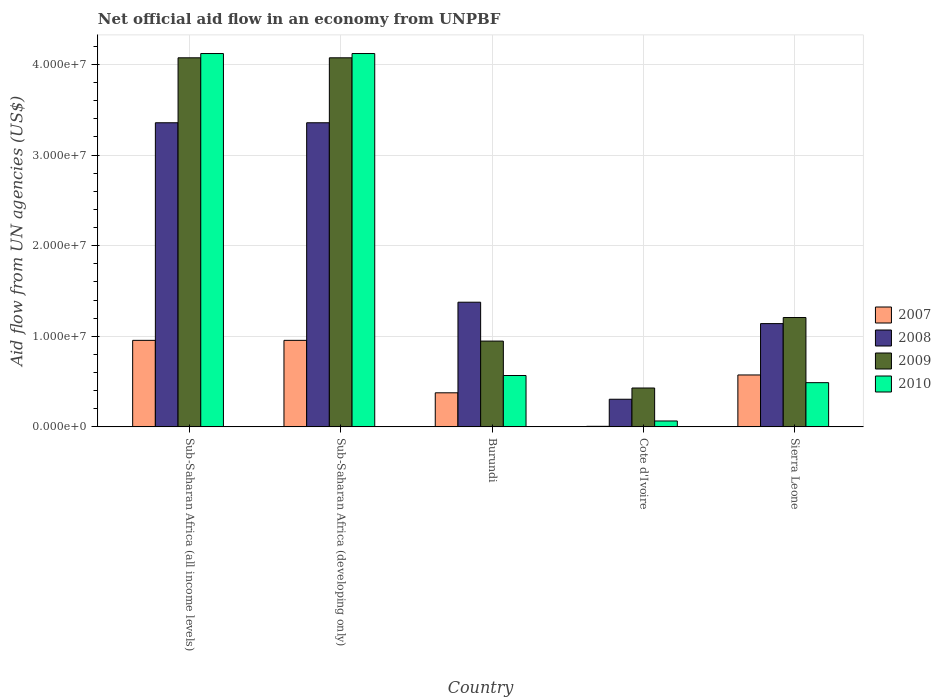How many different coloured bars are there?
Offer a terse response. 4. Are the number of bars per tick equal to the number of legend labels?
Your answer should be very brief. Yes. Are the number of bars on each tick of the X-axis equal?
Offer a very short reply. Yes. How many bars are there on the 4th tick from the left?
Your answer should be very brief. 4. What is the label of the 4th group of bars from the left?
Give a very brief answer. Cote d'Ivoire. In how many cases, is the number of bars for a given country not equal to the number of legend labels?
Offer a very short reply. 0. What is the net official aid flow in 2010 in Sub-Saharan Africa (all income levels)?
Provide a succinct answer. 4.12e+07. Across all countries, what is the maximum net official aid flow in 2008?
Ensure brevity in your answer.  3.36e+07. Across all countries, what is the minimum net official aid flow in 2008?
Keep it short and to the point. 3.05e+06. In which country was the net official aid flow in 2009 maximum?
Your response must be concise. Sub-Saharan Africa (all income levels). In which country was the net official aid flow in 2008 minimum?
Your answer should be compact. Cote d'Ivoire. What is the total net official aid flow in 2009 in the graph?
Provide a short and direct response. 1.07e+08. What is the difference between the net official aid flow in 2009 in Burundi and that in Sub-Saharan Africa (developing only)?
Provide a short and direct response. -3.13e+07. What is the difference between the net official aid flow in 2008 in Sierra Leone and the net official aid flow in 2010 in Sub-Saharan Africa (all income levels)?
Provide a short and direct response. -2.98e+07. What is the average net official aid flow in 2009 per country?
Make the answer very short. 2.15e+07. What is the difference between the net official aid flow of/in 2007 and net official aid flow of/in 2009 in Sub-Saharan Africa (developing only)?
Provide a succinct answer. -3.12e+07. In how many countries, is the net official aid flow in 2007 greater than 36000000 US$?
Make the answer very short. 0. What is the ratio of the net official aid flow in 2009 in Cote d'Ivoire to that in Sub-Saharan Africa (developing only)?
Your answer should be very brief. 0.11. Is the net official aid flow in 2010 in Burundi less than that in Cote d'Ivoire?
Keep it short and to the point. No. Is the difference between the net official aid flow in 2007 in Sub-Saharan Africa (all income levels) and Sub-Saharan Africa (developing only) greater than the difference between the net official aid flow in 2009 in Sub-Saharan Africa (all income levels) and Sub-Saharan Africa (developing only)?
Give a very brief answer. No. What is the difference between the highest and the second highest net official aid flow in 2010?
Your answer should be very brief. 3.55e+07. What is the difference between the highest and the lowest net official aid flow in 2007?
Offer a terse response. 9.49e+06. What does the 4th bar from the left in Burundi represents?
Your answer should be compact. 2010. What does the 1st bar from the right in Cote d'Ivoire represents?
Ensure brevity in your answer.  2010. Are all the bars in the graph horizontal?
Offer a very short reply. No. How many countries are there in the graph?
Keep it short and to the point. 5. What is the difference between two consecutive major ticks on the Y-axis?
Ensure brevity in your answer.  1.00e+07. Are the values on the major ticks of Y-axis written in scientific E-notation?
Make the answer very short. Yes. Does the graph contain grids?
Keep it short and to the point. Yes. Where does the legend appear in the graph?
Make the answer very short. Center right. How many legend labels are there?
Make the answer very short. 4. How are the legend labels stacked?
Offer a terse response. Vertical. What is the title of the graph?
Your answer should be compact. Net official aid flow in an economy from UNPBF. What is the label or title of the X-axis?
Offer a terse response. Country. What is the label or title of the Y-axis?
Keep it short and to the point. Aid flow from UN agencies (US$). What is the Aid flow from UN agencies (US$) of 2007 in Sub-Saharan Africa (all income levels)?
Offer a very short reply. 9.55e+06. What is the Aid flow from UN agencies (US$) in 2008 in Sub-Saharan Africa (all income levels)?
Make the answer very short. 3.36e+07. What is the Aid flow from UN agencies (US$) of 2009 in Sub-Saharan Africa (all income levels)?
Give a very brief answer. 4.07e+07. What is the Aid flow from UN agencies (US$) of 2010 in Sub-Saharan Africa (all income levels)?
Ensure brevity in your answer.  4.12e+07. What is the Aid flow from UN agencies (US$) in 2007 in Sub-Saharan Africa (developing only)?
Your answer should be very brief. 9.55e+06. What is the Aid flow from UN agencies (US$) in 2008 in Sub-Saharan Africa (developing only)?
Provide a succinct answer. 3.36e+07. What is the Aid flow from UN agencies (US$) in 2009 in Sub-Saharan Africa (developing only)?
Make the answer very short. 4.07e+07. What is the Aid flow from UN agencies (US$) in 2010 in Sub-Saharan Africa (developing only)?
Ensure brevity in your answer.  4.12e+07. What is the Aid flow from UN agencies (US$) in 2007 in Burundi?
Your response must be concise. 3.76e+06. What is the Aid flow from UN agencies (US$) in 2008 in Burundi?
Offer a terse response. 1.38e+07. What is the Aid flow from UN agencies (US$) in 2009 in Burundi?
Provide a succinct answer. 9.47e+06. What is the Aid flow from UN agencies (US$) in 2010 in Burundi?
Make the answer very short. 5.67e+06. What is the Aid flow from UN agencies (US$) in 2007 in Cote d'Ivoire?
Provide a short and direct response. 6.00e+04. What is the Aid flow from UN agencies (US$) of 2008 in Cote d'Ivoire?
Make the answer very short. 3.05e+06. What is the Aid flow from UN agencies (US$) of 2009 in Cote d'Ivoire?
Give a very brief answer. 4.29e+06. What is the Aid flow from UN agencies (US$) of 2010 in Cote d'Ivoire?
Your response must be concise. 6.50e+05. What is the Aid flow from UN agencies (US$) of 2007 in Sierra Leone?
Provide a succinct answer. 5.73e+06. What is the Aid flow from UN agencies (US$) of 2008 in Sierra Leone?
Your answer should be compact. 1.14e+07. What is the Aid flow from UN agencies (US$) of 2009 in Sierra Leone?
Offer a terse response. 1.21e+07. What is the Aid flow from UN agencies (US$) of 2010 in Sierra Leone?
Ensure brevity in your answer.  4.88e+06. Across all countries, what is the maximum Aid flow from UN agencies (US$) of 2007?
Your answer should be compact. 9.55e+06. Across all countries, what is the maximum Aid flow from UN agencies (US$) in 2008?
Provide a succinct answer. 3.36e+07. Across all countries, what is the maximum Aid flow from UN agencies (US$) of 2009?
Your answer should be compact. 4.07e+07. Across all countries, what is the maximum Aid flow from UN agencies (US$) of 2010?
Your response must be concise. 4.12e+07. Across all countries, what is the minimum Aid flow from UN agencies (US$) in 2008?
Offer a terse response. 3.05e+06. Across all countries, what is the minimum Aid flow from UN agencies (US$) in 2009?
Ensure brevity in your answer.  4.29e+06. Across all countries, what is the minimum Aid flow from UN agencies (US$) in 2010?
Keep it short and to the point. 6.50e+05. What is the total Aid flow from UN agencies (US$) in 2007 in the graph?
Offer a very short reply. 2.86e+07. What is the total Aid flow from UN agencies (US$) of 2008 in the graph?
Your answer should be very brief. 9.54e+07. What is the total Aid flow from UN agencies (US$) of 2009 in the graph?
Provide a succinct answer. 1.07e+08. What is the total Aid flow from UN agencies (US$) in 2010 in the graph?
Give a very brief answer. 9.36e+07. What is the difference between the Aid flow from UN agencies (US$) of 2010 in Sub-Saharan Africa (all income levels) and that in Sub-Saharan Africa (developing only)?
Your answer should be very brief. 0. What is the difference between the Aid flow from UN agencies (US$) of 2007 in Sub-Saharan Africa (all income levels) and that in Burundi?
Keep it short and to the point. 5.79e+06. What is the difference between the Aid flow from UN agencies (US$) of 2008 in Sub-Saharan Africa (all income levels) and that in Burundi?
Keep it short and to the point. 1.98e+07. What is the difference between the Aid flow from UN agencies (US$) in 2009 in Sub-Saharan Africa (all income levels) and that in Burundi?
Offer a very short reply. 3.13e+07. What is the difference between the Aid flow from UN agencies (US$) in 2010 in Sub-Saharan Africa (all income levels) and that in Burundi?
Offer a terse response. 3.55e+07. What is the difference between the Aid flow from UN agencies (US$) of 2007 in Sub-Saharan Africa (all income levels) and that in Cote d'Ivoire?
Make the answer very short. 9.49e+06. What is the difference between the Aid flow from UN agencies (US$) in 2008 in Sub-Saharan Africa (all income levels) and that in Cote d'Ivoire?
Provide a succinct answer. 3.05e+07. What is the difference between the Aid flow from UN agencies (US$) of 2009 in Sub-Saharan Africa (all income levels) and that in Cote d'Ivoire?
Your answer should be very brief. 3.64e+07. What is the difference between the Aid flow from UN agencies (US$) in 2010 in Sub-Saharan Africa (all income levels) and that in Cote d'Ivoire?
Your response must be concise. 4.06e+07. What is the difference between the Aid flow from UN agencies (US$) of 2007 in Sub-Saharan Africa (all income levels) and that in Sierra Leone?
Your response must be concise. 3.82e+06. What is the difference between the Aid flow from UN agencies (US$) in 2008 in Sub-Saharan Africa (all income levels) and that in Sierra Leone?
Your response must be concise. 2.22e+07. What is the difference between the Aid flow from UN agencies (US$) of 2009 in Sub-Saharan Africa (all income levels) and that in Sierra Leone?
Make the answer very short. 2.87e+07. What is the difference between the Aid flow from UN agencies (US$) in 2010 in Sub-Saharan Africa (all income levels) and that in Sierra Leone?
Offer a terse response. 3.63e+07. What is the difference between the Aid flow from UN agencies (US$) in 2007 in Sub-Saharan Africa (developing only) and that in Burundi?
Keep it short and to the point. 5.79e+06. What is the difference between the Aid flow from UN agencies (US$) of 2008 in Sub-Saharan Africa (developing only) and that in Burundi?
Provide a short and direct response. 1.98e+07. What is the difference between the Aid flow from UN agencies (US$) of 2009 in Sub-Saharan Africa (developing only) and that in Burundi?
Your answer should be compact. 3.13e+07. What is the difference between the Aid flow from UN agencies (US$) of 2010 in Sub-Saharan Africa (developing only) and that in Burundi?
Offer a terse response. 3.55e+07. What is the difference between the Aid flow from UN agencies (US$) of 2007 in Sub-Saharan Africa (developing only) and that in Cote d'Ivoire?
Provide a short and direct response. 9.49e+06. What is the difference between the Aid flow from UN agencies (US$) in 2008 in Sub-Saharan Africa (developing only) and that in Cote d'Ivoire?
Make the answer very short. 3.05e+07. What is the difference between the Aid flow from UN agencies (US$) in 2009 in Sub-Saharan Africa (developing only) and that in Cote d'Ivoire?
Make the answer very short. 3.64e+07. What is the difference between the Aid flow from UN agencies (US$) of 2010 in Sub-Saharan Africa (developing only) and that in Cote d'Ivoire?
Make the answer very short. 4.06e+07. What is the difference between the Aid flow from UN agencies (US$) of 2007 in Sub-Saharan Africa (developing only) and that in Sierra Leone?
Provide a short and direct response. 3.82e+06. What is the difference between the Aid flow from UN agencies (US$) in 2008 in Sub-Saharan Africa (developing only) and that in Sierra Leone?
Keep it short and to the point. 2.22e+07. What is the difference between the Aid flow from UN agencies (US$) of 2009 in Sub-Saharan Africa (developing only) and that in Sierra Leone?
Your response must be concise. 2.87e+07. What is the difference between the Aid flow from UN agencies (US$) of 2010 in Sub-Saharan Africa (developing only) and that in Sierra Leone?
Give a very brief answer. 3.63e+07. What is the difference between the Aid flow from UN agencies (US$) of 2007 in Burundi and that in Cote d'Ivoire?
Your answer should be very brief. 3.70e+06. What is the difference between the Aid flow from UN agencies (US$) in 2008 in Burundi and that in Cote d'Ivoire?
Your answer should be compact. 1.07e+07. What is the difference between the Aid flow from UN agencies (US$) in 2009 in Burundi and that in Cote d'Ivoire?
Make the answer very short. 5.18e+06. What is the difference between the Aid flow from UN agencies (US$) in 2010 in Burundi and that in Cote d'Ivoire?
Keep it short and to the point. 5.02e+06. What is the difference between the Aid flow from UN agencies (US$) in 2007 in Burundi and that in Sierra Leone?
Provide a short and direct response. -1.97e+06. What is the difference between the Aid flow from UN agencies (US$) in 2008 in Burundi and that in Sierra Leone?
Your answer should be very brief. 2.36e+06. What is the difference between the Aid flow from UN agencies (US$) of 2009 in Burundi and that in Sierra Leone?
Provide a succinct answer. -2.60e+06. What is the difference between the Aid flow from UN agencies (US$) of 2010 in Burundi and that in Sierra Leone?
Offer a very short reply. 7.90e+05. What is the difference between the Aid flow from UN agencies (US$) in 2007 in Cote d'Ivoire and that in Sierra Leone?
Your answer should be very brief. -5.67e+06. What is the difference between the Aid flow from UN agencies (US$) of 2008 in Cote d'Ivoire and that in Sierra Leone?
Ensure brevity in your answer.  -8.35e+06. What is the difference between the Aid flow from UN agencies (US$) in 2009 in Cote d'Ivoire and that in Sierra Leone?
Ensure brevity in your answer.  -7.78e+06. What is the difference between the Aid flow from UN agencies (US$) of 2010 in Cote d'Ivoire and that in Sierra Leone?
Give a very brief answer. -4.23e+06. What is the difference between the Aid flow from UN agencies (US$) in 2007 in Sub-Saharan Africa (all income levels) and the Aid flow from UN agencies (US$) in 2008 in Sub-Saharan Africa (developing only)?
Give a very brief answer. -2.40e+07. What is the difference between the Aid flow from UN agencies (US$) in 2007 in Sub-Saharan Africa (all income levels) and the Aid flow from UN agencies (US$) in 2009 in Sub-Saharan Africa (developing only)?
Provide a succinct answer. -3.12e+07. What is the difference between the Aid flow from UN agencies (US$) of 2007 in Sub-Saharan Africa (all income levels) and the Aid flow from UN agencies (US$) of 2010 in Sub-Saharan Africa (developing only)?
Provide a succinct answer. -3.17e+07. What is the difference between the Aid flow from UN agencies (US$) of 2008 in Sub-Saharan Africa (all income levels) and the Aid flow from UN agencies (US$) of 2009 in Sub-Saharan Africa (developing only)?
Keep it short and to the point. -7.17e+06. What is the difference between the Aid flow from UN agencies (US$) in 2008 in Sub-Saharan Africa (all income levels) and the Aid flow from UN agencies (US$) in 2010 in Sub-Saharan Africa (developing only)?
Make the answer very short. -7.64e+06. What is the difference between the Aid flow from UN agencies (US$) of 2009 in Sub-Saharan Africa (all income levels) and the Aid flow from UN agencies (US$) of 2010 in Sub-Saharan Africa (developing only)?
Offer a terse response. -4.70e+05. What is the difference between the Aid flow from UN agencies (US$) of 2007 in Sub-Saharan Africa (all income levels) and the Aid flow from UN agencies (US$) of 2008 in Burundi?
Provide a succinct answer. -4.21e+06. What is the difference between the Aid flow from UN agencies (US$) of 2007 in Sub-Saharan Africa (all income levels) and the Aid flow from UN agencies (US$) of 2009 in Burundi?
Ensure brevity in your answer.  8.00e+04. What is the difference between the Aid flow from UN agencies (US$) of 2007 in Sub-Saharan Africa (all income levels) and the Aid flow from UN agencies (US$) of 2010 in Burundi?
Offer a very short reply. 3.88e+06. What is the difference between the Aid flow from UN agencies (US$) in 2008 in Sub-Saharan Africa (all income levels) and the Aid flow from UN agencies (US$) in 2009 in Burundi?
Offer a terse response. 2.41e+07. What is the difference between the Aid flow from UN agencies (US$) of 2008 in Sub-Saharan Africa (all income levels) and the Aid flow from UN agencies (US$) of 2010 in Burundi?
Your response must be concise. 2.79e+07. What is the difference between the Aid flow from UN agencies (US$) of 2009 in Sub-Saharan Africa (all income levels) and the Aid flow from UN agencies (US$) of 2010 in Burundi?
Make the answer very short. 3.51e+07. What is the difference between the Aid flow from UN agencies (US$) in 2007 in Sub-Saharan Africa (all income levels) and the Aid flow from UN agencies (US$) in 2008 in Cote d'Ivoire?
Offer a very short reply. 6.50e+06. What is the difference between the Aid flow from UN agencies (US$) of 2007 in Sub-Saharan Africa (all income levels) and the Aid flow from UN agencies (US$) of 2009 in Cote d'Ivoire?
Ensure brevity in your answer.  5.26e+06. What is the difference between the Aid flow from UN agencies (US$) in 2007 in Sub-Saharan Africa (all income levels) and the Aid flow from UN agencies (US$) in 2010 in Cote d'Ivoire?
Provide a succinct answer. 8.90e+06. What is the difference between the Aid flow from UN agencies (US$) in 2008 in Sub-Saharan Africa (all income levels) and the Aid flow from UN agencies (US$) in 2009 in Cote d'Ivoire?
Keep it short and to the point. 2.93e+07. What is the difference between the Aid flow from UN agencies (US$) of 2008 in Sub-Saharan Africa (all income levels) and the Aid flow from UN agencies (US$) of 2010 in Cote d'Ivoire?
Give a very brief answer. 3.29e+07. What is the difference between the Aid flow from UN agencies (US$) in 2009 in Sub-Saharan Africa (all income levels) and the Aid flow from UN agencies (US$) in 2010 in Cote d'Ivoire?
Your answer should be very brief. 4.01e+07. What is the difference between the Aid flow from UN agencies (US$) of 2007 in Sub-Saharan Africa (all income levels) and the Aid flow from UN agencies (US$) of 2008 in Sierra Leone?
Provide a succinct answer. -1.85e+06. What is the difference between the Aid flow from UN agencies (US$) in 2007 in Sub-Saharan Africa (all income levels) and the Aid flow from UN agencies (US$) in 2009 in Sierra Leone?
Your answer should be very brief. -2.52e+06. What is the difference between the Aid flow from UN agencies (US$) in 2007 in Sub-Saharan Africa (all income levels) and the Aid flow from UN agencies (US$) in 2010 in Sierra Leone?
Offer a very short reply. 4.67e+06. What is the difference between the Aid flow from UN agencies (US$) in 2008 in Sub-Saharan Africa (all income levels) and the Aid flow from UN agencies (US$) in 2009 in Sierra Leone?
Give a very brief answer. 2.15e+07. What is the difference between the Aid flow from UN agencies (US$) in 2008 in Sub-Saharan Africa (all income levels) and the Aid flow from UN agencies (US$) in 2010 in Sierra Leone?
Your response must be concise. 2.87e+07. What is the difference between the Aid flow from UN agencies (US$) in 2009 in Sub-Saharan Africa (all income levels) and the Aid flow from UN agencies (US$) in 2010 in Sierra Leone?
Make the answer very short. 3.59e+07. What is the difference between the Aid flow from UN agencies (US$) in 2007 in Sub-Saharan Africa (developing only) and the Aid flow from UN agencies (US$) in 2008 in Burundi?
Make the answer very short. -4.21e+06. What is the difference between the Aid flow from UN agencies (US$) in 2007 in Sub-Saharan Africa (developing only) and the Aid flow from UN agencies (US$) in 2010 in Burundi?
Make the answer very short. 3.88e+06. What is the difference between the Aid flow from UN agencies (US$) in 2008 in Sub-Saharan Africa (developing only) and the Aid flow from UN agencies (US$) in 2009 in Burundi?
Offer a terse response. 2.41e+07. What is the difference between the Aid flow from UN agencies (US$) in 2008 in Sub-Saharan Africa (developing only) and the Aid flow from UN agencies (US$) in 2010 in Burundi?
Provide a short and direct response. 2.79e+07. What is the difference between the Aid flow from UN agencies (US$) of 2009 in Sub-Saharan Africa (developing only) and the Aid flow from UN agencies (US$) of 2010 in Burundi?
Ensure brevity in your answer.  3.51e+07. What is the difference between the Aid flow from UN agencies (US$) of 2007 in Sub-Saharan Africa (developing only) and the Aid flow from UN agencies (US$) of 2008 in Cote d'Ivoire?
Offer a terse response. 6.50e+06. What is the difference between the Aid flow from UN agencies (US$) in 2007 in Sub-Saharan Africa (developing only) and the Aid flow from UN agencies (US$) in 2009 in Cote d'Ivoire?
Offer a terse response. 5.26e+06. What is the difference between the Aid flow from UN agencies (US$) of 2007 in Sub-Saharan Africa (developing only) and the Aid flow from UN agencies (US$) of 2010 in Cote d'Ivoire?
Give a very brief answer. 8.90e+06. What is the difference between the Aid flow from UN agencies (US$) of 2008 in Sub-Saharan Africa (developing only) and the Aid flow from UN agencies (US$) of 2009 in Cote d'Ivoire?
Make the answer very short. 2.93e+07. What is the difference between the Aid flow from UN agencies (US$) in 2008 in Sub-Saharan Africa (developing only) and the Aid flow from UN agencies (US$) in 2010 in Cote d'Ivoire?
Offer a very short reply. 3.29e+07. What is the difference between the Aid flow from UN agencies (US$) in 2009 in Sub-Saharan Africa (developing only) and the Aid flow from UN agencies (US$) in 2010 in Cote d'Ivoire?
Provide a succinct answer. 4.01e+07. What is the difference between the Aid flow from UN agencies (US$) in 2007 in Sub-Saharan Africa (developing only) and the Aid flow from UN agencies (US$) in 2008 in Sierra Leone?
Keep it short and to the point. -1.85e+06. What is the difference between the Aid flow from UN agencies (US$) of 2007 in Sub-Saharan Africa (developing only) and the Aid flow from UN agencies (US$) of 2009 in Sierra Leone?
Ensure brevity in your answer.  -2.52e+06. What is the difference between the Aid flow from UN agencies (US$) in 2007 in Sub-Saharan Africa (developing only) and the Aid flow from UN agencies (US$) in 2010 in Sierra Leone?
Offer a terse response. 4.67e+06. What is the difference between the Aid flow from UN agencies (US$) in 2008 in Sub-Saharan Africa (developing only) and the Aid flow from UN agencies (US$) in 2009 in Sierra Leone?
Make the answer very short. 2.15e+07. What is the difference between the Aid flow from UN agencies (US$) of 2008 in Sub-Saharan Africa (developing only) and the Aid flow from UN agencies (US$) of 2010 in Sierra Leone?
Your response must be concise. 2.87e+07. What is the difference between the Aid flow from UN agencies (US$) in 2009 in Sub-Saharan Africa (developing only) and the Aid flow from UN agencies (US$) in 2010 in Sierra Leone?
Your response must be concise. 3.59e+07. What is the difference between the Aid flow from UN agencies (US$) of 2007 in Burundi and the Aid flow from UN agencies (US$) of 2008 in Cote d'Ivoire?
Offer a terse response. 7.10e+05. What is the difference between the Aid flow from UN agencies (US$) in 2007 in Burundi and the Aid flow from UN agencies (US$) in 2009 in Cote d'Ivoire?
Your answer should be compact. -5.30e+05. What is the difference between the Aid flow from UN agencies (US$) of 2007 in Burundi and the Aid flow from UN agencies (US$) of 2010 in Cote d'Ivoire?
Your response must be concise. 3.11e+06. What is the difference between the Aid flow from UN agencies (US$) of 2008 in Burundi and the Aid flow from UN agencies (US$) of 2009 in Cote d'Ivoire?
Ensure brevity in your answer.  9.47e+06. What is the difference between the Aid flow from UN agencies (US$) in 2008 in Burundi and the Aid flow from UN agencies (US$) in 2010 in Cote d'Ivoire?
Your response must be concise. 1.31e+07. What is the difference between the Aid flow from UN agencies (US$) in 2009 in Burundi and the Aid flow from UN agencies (US$) in 2010 in Cote d'Ivoire?
Provide a succinct answer. 8.82e+06. What is the difference between the Aid flow from UN agencies (US$) in 2007 in Burundi and the Aid flow from UN agencies (US$) in 2008 in Sierra Leone?
Keep it short and to the point. -7.64e+06. What is the difference between the Aid flow from UN agencies (US$) in 2007 in Burundi and the Aid flow from UN agencies (US$) in 2009 in Sierra Leone?
Provide a short and direct response. -8.31e+06. What is the difference between the Aid flow from UN agencies (US$) in 2007 in Burundi and the Aid flow from UN agencies (US$) in 2010 in Sierra Leone?
Your answer should be very brief. -1.12e+06. What is the difference between the Aid flow from UN agencies (US$) of 2008 in Burundi and the Aid flow from UN agencies (US$) of 2009 in Sierra Leone?
Offer a very short reply. 1.69e+06. What is the difference between the Aid flow from UN agencies (US$) of 2008 in Burundi and the Aid flow from UN agencies (US$) of 2010 in Sierra Leone?
Your answer should be compact. 8.88e+06. What is the difference between the Aid flow from UN agencies (US$) in 2009 in Burundi and the Aid flow from UN agencies (US$) in 2010 in Sierra Leone?
Ensure brevity in your answer.  4.59e+06. What is the difference between the Aid flow from UN agencies (US$) of 2007 in Cote d'Ivoire and the Aid flow from UN agencies (US$) of 2008 in Sierra Leone?
Make the answer very short. -1.13e+07. What is the difference between the Aid flow from UN agencies (US$) in 2007 in Cote d'Ivoire and the Aid flow from UN agencies (US$) in 2009 in Sierra Leone?
Give a very brief answer. -1.20e+07. What is the difference between the Aid flow from UN agencies (US$) in 2007 in Cote d'Ivoire and the Aid flow from UN agencies (US$) in 2010 in Sierra Leone?
Provide a succinct answer. -4.82e+06. What is the difference between the Aid flow from UN agencies (US$) of 2008 in Cote d'Ivoire and the Aid flow from UN agencies (US$) of 2009 in Sierra Leone?
Your response must be concise. -9.02e+06. What is the difference between the Aid flow from UN agencies (US$) in 2008 in Cote d'Ivoire and the Aid flow from UN agencies (US$) in 2010 in Sierra Leone?
Offer a very short reply. -1.83e+06. What is the difference between the Aid flow from UN agencies (US$) in 2009 in Cote d'Ivoire and the Aid flow from UN agencies (US$) in 2010 in Sierra Leone?
Provide a succinct answer. -5.90e+05. What is the average Aid flow from UN agencies (US$) in 2007 per country?
Offer a very short reply. 5.73e+06. What is the average Aid flow from UN agencies (US$) of 2008 per country?
Provide a succinct answer. 1.91e+07. What is the average Aid flow from UN agencies (US$) in 2009 per country?
Make the answer very short. 2.15e+07. What is the average Aid flow from UN agencies (US$) in 2010 per country?
Give a very brief answer. 1.87e+07. What is the difference between the Aid flow from UN agencies (US$) in 2007 and Aid flow from UN agencies (US$) in 2008 in Sub-Saharan Africa (all income levels)?
Offer a very short reply. -2.40e+07. What is the difference between the Aid flow from UN agencies (US$) of 2007 and Aid flow from UN agencies (US$) of 2009 in Sub-Saharan Africa (all income levels)?
Keep it short and to the point. -3.12e+07. What is the difference between the Aid flow from UN agencies (US$) of 2007 and Aid flow from UN agencies (US$) of 2010 in Sub-Saharan Africa (all income levels)?
Give a very brief answer. -3.17e+07. What is the difference between the Aid flow from UN agencies (US$) of 2008 and Aid flow from UN agencies (US$) of 2009 in Sub-Saharan Africa (all income levels)?
Provide a short and direct response. -7.17e+06. What is the difference between the Aid flow from UN agencies (US$) of 2008 and Aid flow from UN agencies (US$) of 2010 in Sub-Saharan Africa (all income levels)?
Your answer should be compact. -7.64e+06. What is the difference between the Aid flow from UN agencies (US$) in 2009 and Aid flow from UN agencies (US$) in 2010 in Sub-Saharan Africa (all income levels)?
Make the answer very short. -4.70e+05. What is the difference between the Aid flow from UN agencies (US$) of 2007 and Aid flow from UN agencies (US$) of 2008 in Sub-Saharan Africa (developing only)?
Give a very brief answer. -2.40e+07. What is the difference between the Aid flow from UN agencies (US$) in 2007 and Aid flow from UN agencies (US$) in 2009 in Sub-Saharan Africa (developing only)?
Provide a succinct answer. -3.12e+07. What is the difference between the Aid flow from UN agencies (US$) in 2007 and Aid flow from UN agencies (US$) in 2010 in Sub-Saharan Africa (developing only)?
Your answer should be very brief. -3.17e+07. What is the difference between the Aid flow from UN agencies (US$) of 2008 and Aid flow from UN agencies (US$) of 2009 in Sub-Saharan Africa (developing only)?
Provide a succinct answer. -7.17e+06. What is the difference between the Aid flow from UN agencies (US$) of 2008 and Aid flow from UN agencies (US$) of 2010 in Sub-Saharan Africa (developing only)?
Your answer should be compact. -7.64e+06. What is the difference between the Aid flow from UN agencies (US$) in 2009 and Aid flow from UN agencies (US$) in 2010 in Sub-Saharan Africa (developing only)?
Your answer should be compact. -4.70e+05. What is the difference between the Aid flow from UN agencies (US$) in 2007 and Aid flow from UN agencies (US$) in 2008 in Burundi?
Provide a short and direct response. -1.00e+07. What is the difference between the Aid flow from UN agencies (US$) of 2007 and Aid flow from UN agencies (US$) of 2009 in Burundi?
Provide a succinct answer. -5.71e+06. What is the difference between the Aid flow from UN agencies (US$) in 2007 and Aid flow from UN agencies (US$) in 2010 in Burundi?
Keep it short and to the point. -1.91e+06. What is the difference between the Aid flow from UN agencies (US$) in 2008 and Aid flow from UN agencies (US$) in 2009 in Burundi?
Your response must be concise. 4.29e+06. What is the difference between the Aid flow from UN agencies (US$) of 2008 and Aid flow from UN agencies (US$) of 2010 in Burundi?
Provide a short and direct response. 8.09e+06. What is the difference between the Aid flow from UN agencies (US$) of 2009 and Aid flow from UN agencies (US$) of 2010 in Burundi?
Ensure brevity in your answer.  3.80e+06. What is the difference between the Aid flow from UN agencies (US$) of 2007 and Aid flow from UN agencies (US$) of 2008 in Cote d'Ivoire?
Keep it short and to the point. -2.99e+06. What is the difference between the Aid flow from UN agencies (US$) of 2007 and Aid flow from UN agencies (US$) of 2009 in Cote d'Ivoire?
Provide a short and direct response. -4.23e+06. What is the difference between the Aid flow from UN agencies (US$) in 2007 and Aid flow from UN agencies (US$) in 2010 in Cote d'Ivoire?
Provide a short and direct response. -5.90e+05. What is the difference between the Aid flow from UN agencies (US$) of 2008 and Aid flow from UN agencies (US$) of 2009 in Cote d'Ivoire?
Your answer should be very brief. -1.24e+06. What is the difference between the Aid flow from UN agencies (US$) in 2008 and Aid flow from UN agencies (US$) in 2010 in Cote d'Ivoire?
Your answer should be very brief. 2.40e+06. What is the difference between the Aid flow from UN agencies (US$) of 2009 and Aid flow from UN agencies (US$) of 2010 in Cote d'Ivoire?
Keep it short and to the point. 3.64e+06. What is the difference between the Aid flow from UN agencies (US$) in 2007 and Aid flow from UN agencies (US$) in 2008 in Sierra Leone?
Your answer should be compact. -5.67e+06. What is the difference between the Aid flow from UN agencies (US$) of 2007 and Aid flow from UN agencies (US$) of 2009 in Sierra Leone?
Make the answer very short. -6.34e+06. What is the difference between the Aid flow from UN agencies (US$) of 2007 and Aid flow from UN agencies (US$) of 2010 in Sierra Leone?
Provide a short and direct response. 8.50e+05. What is the difference between the Aid flow from UN agencies (US$) in 2008 and Aid flow from UN agencies (US$) in 2009 in Sierra Leone?
Offer a very short reply. -6.70e+05. What is the difference between the Aid flow from UN agencies (US$) in 2008 and Aid flow from UN agencies (US$) in 2010 in Sierra Leone?
Your answer should be compact. 6.52e+06. What is the difference between the Aid flow from UN agencies (US$) of 2009 and Aid flow from UN agencies (US$) of 2010 in Sierra Leone?
Provide a succinct answer. 7.19e+06. What is the ratio of the Aid flow from UN agencies (US$) of 2007 in Sub-Saharan Africa (all income levels) to that in Burundi?
Provide a short and direct response. 2.54. What is the ratio of the Aid flow from UN agencies (US$) in 2008 in Sub-Saharan Africa (all income levels) to that in Burundi?
Keep it short and to the point. 2.44. What is the ratio of the Aid flow from UN agencies (US$) of 2009 in Sub-Saharan Africa (all income levels) to that in Burundi?
Offer a very short reply. 4.3. What is the ratio of the Aid flow from UN agencies (US$) in 2010 in Sub-Saharan Africa (all income levels) to that in Burundi?
Keep it short and to the point. 7.27. What is the ratio of the Aid flow from UN agencies (US$) of 2007 in Sub-Saharan Africa (all income levels) to that in Cote d'Ivoire?
Offer a terse response. 159.17. What is the ratio of the Aid flow from UN agencies (US$) of 2008 in Sub-Saharan Africa (all income levels) to that in Cote d'Ivoire?
Give a very brief answer. 11.01. What is the ratio of the Aid flow from UN agencies (US$) of 2009 in Sub-Saharan Africa (all income levels) to that in Cote d'Ivoire?
Your answer should be very brief. 9.5. What is the ratio of the Aid flow from UN agencies (US$) of 2010 in Sub-Saharan Africa (all income levels) to that in Cote d'Ivoire?
Provide a short and direct response. 63.4. What is the ratio of the Aid flow from UN agencies (US$) in 2007 in Sub-Saharan Africa (all income levels) to that in Sierra Leone?
Provide a succinct answer. 1.67. What is the ratio of the Aid flow from UN agencies (US$) of 2008 in Sub-Saharan Africa (all income levels) to that in Sierra Leone?
Offer a terse response. 2.94. What is the ratio of the Aid flow from UN agencies (US$) of 2009 in Sub-Saharan Africa (all income levels) to that in Sierra Leone?
Ensure brevity in your answer.  3.38. What is the ratio of the Aid flow from UN agencies (US$) in 2010 in Sub-Saharan Africa (all income levels) to that in Sierra Leone?
Provide a short and direct response. 8.44. What is the ratio of the Aid flow from UN agencies (US$) in 2007 in Sub-Saharan Africa (developing only) to that in Burundi?
Give a very brief answer. 2.54. What is the ratio of the Aid flow from UN agencies (US$) in 2008 in Sub-Saharan Africa (developing only) to that in Burundi?
Your response must be concise. 2.44. What is the ratio of the Aid flow from UN agencies (US$) of 2009 in Sub-Saharan Africa (developing only) to that in Burundi?
Make the answer very short. 4.3. What is the ratio of the Aid flow from UN agencies (US$) in 2010 in Sub-Saharan Africa (developing only) to that in Burundi?
Your answer should be compact. 7.27. What is the ratio of the Aid flow from UN agencies (US$) in 2007 in Sub-Saharan Africa (developing only) to that in Cote d'Ivoire?
Your response must be concise. 159.17. What is the ratio of the Aid flow from UN agencies (US$) of 2008 in Sub-Saharan Africa (developing only) to that in Cote d'Ivoire?
Your response must be concise. 11.01. What is the ratio of the Aid flow from UN agencies (US$) in 2009 in Sub-Saharan Africa (developing only) to that in Cote d'Ivoire?
Provide a succinct answer. 9.5. What is the ratio of the Aid flow from UN agencies (US$) of 2010 in Sub-Saharan Africa (developing only) to that in Cote d'Ivoire?
Offer a terse response. 63.4. What is the ratio of the Aid flow from UN agencies (US$) of 2008 in Sub-Saharan Africa (developing only) to that in Sierra Leone?
Provide a short and direct response. 2.94. What is the ratio of the Aid flow from UN agencies (US$) in 2009 in Sub-Saharan Africa (developing only) to that in Sierra Leone?
Provide a short and direct response. 3.38. What is the ratio of the Aid flow from UN agencies (US$) in 2010 in Sub-Saharan Africa (developing only) to that in Sierra Leone?
Your answer should be very brief. 8.44. What is the ratio of the Aid flow from UN agencies (US$) in 2007 in Burundi to that in Cote d'Ivoire?
Make the answer very short. 62.67. What is the ratio of the Aid flow from UN agencies (US$) of 2008 in Burundi to that in Cote d'Ivoire?
Your answer should be very brief. 4.51. What is the ratio of the Aid flow from UN agencies (US$) of 2009 in Burundi to that in Cote d'Ivoire?
Your answer should be compact. 2.21. What is the ratio of the Aid flow from UN agencies (US$) in 2010 in Burundi to that in Cote d'Ivoire?
Offer a terse response. 8.72. What is the ratio of the Aid flow from UN agencies (US$) of 2007 in Burundi to that in Sierra Leone?
Make the answer very short. 0.66. What is the ratio of the Aid flow from UN agencies (US$) in 2008 in Burundi to that in Sierra Leone?
Offer a terse response. 1.21. What is the ratio of the Aid flow from UN agencies (US$) of 2009 in Burundi to that in Sierra Leone?
Your answer should be very brief. 0.78. What is the ratio of the Aid flow from UN agencies (US$) of 2010 in Burundi to that in Sierra Leone?
Offer a very short reply. 1.16. What is the ratio of the Aid flow from UN agencies (US$) in 2007 in Cote d'Ivoire to that in Sierra Leone?
Your response must be concise. 0.01. What is the ratio of the Aid flow from UN agencies (US$) of 2008 in Cote d'Ivoire to that in Sierra Leone?
Ensure brevity in your answer.  0.27. What is the ratio of the Aid flow from UN agencies (US$) of 2009 in Cote d'Ivoire to that in Sierra Leone?
Your response must be concise. 0.36. What is the ratio of the Aid flow from UN agencies (US$) in 2010 in Cote d'Ivoire to that in Sierra Leone?
Ensure brevity in your answer.  0.13. What is the difference between the highest and the second highest Aid flow from UN agencies (US$) in 2008?
Your answer should be compact. 0. What is the difference between the highest and the second highest Aid flow from UN agencies (US$) in 2009?
Make the answer very short. 0. What is the difference between the highest and the second highest Aid flow from UN agencies (US$) of 2010?
Make the answer very short. 0. What is the difference between the highest and the lowest Aid flow from UN agencies (US$) in 2007?
Your answer should be very brief. 9.49e+06. What is the difference between the highest and the lowest Aid flow from UN agencies (US$) in 2008?
Your answer should be very brief. 3.05e+07. What is the difference between the highest and the lowest Aid flow from UN agencies (US$) of 2009?
Provide a short and direct response. 3.64e+07. What is the difference between the highest and the lowest Aid flow from UN agencies (US$) of 2010?
Make the answer very short. 4.06e+07. 